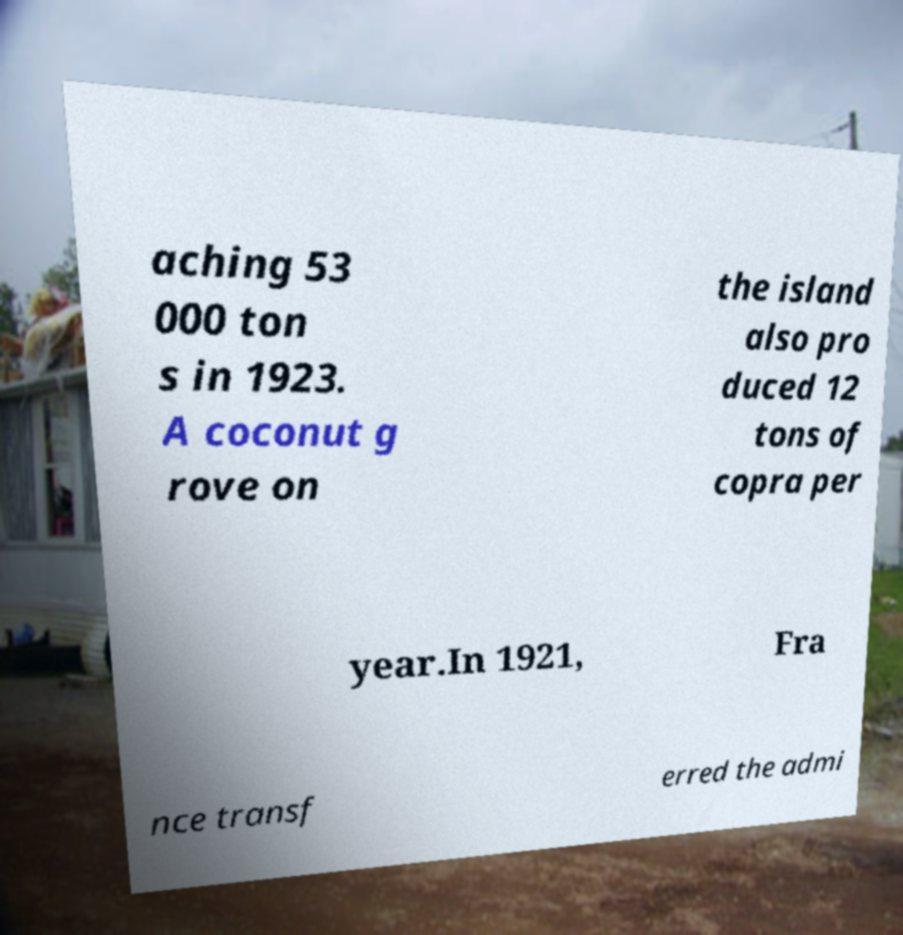There's text embedded in this image that I need extracted. Can you transcribe it verbatim? aching 53 000 ton s in 1923. A coconut g rove on the island also pro duced 12 tons of copra per year.In 1921, Fra nce transf erred the admi 